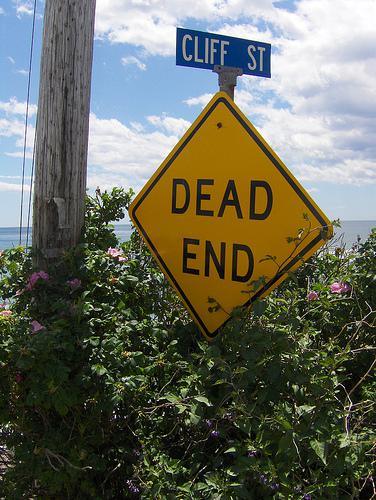Question: what does the blue sign say?
Choices:
A. Estelle Ave.
B. Cliff st.
C. Poplar Level Rd.
D. Brooke St.
Answer with the letter. Answer: B Question: where is the Cliff St sign?
Choices:
A. Below the red light.
B. Behind a car.
C. Beside a tree.
D. Above the yellow sign.
Answer with the letter. Answer: D 